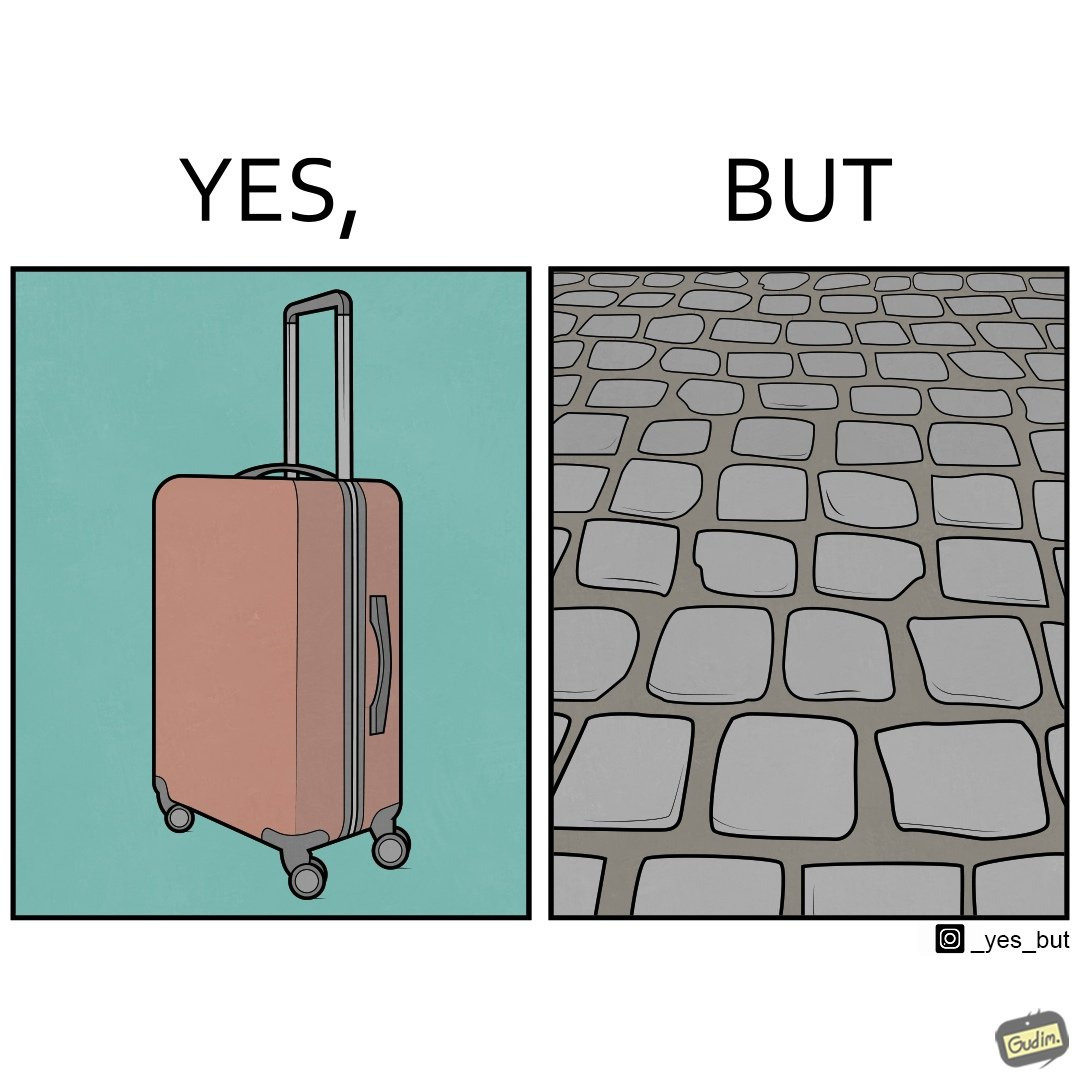Explain the humor or irony in this image. The image is funny because even though the trolley bag is made to make carrying luggage easy, as soon as it encounters a rough surface like cobblestone road, it makes carrying luggage more difficult. 